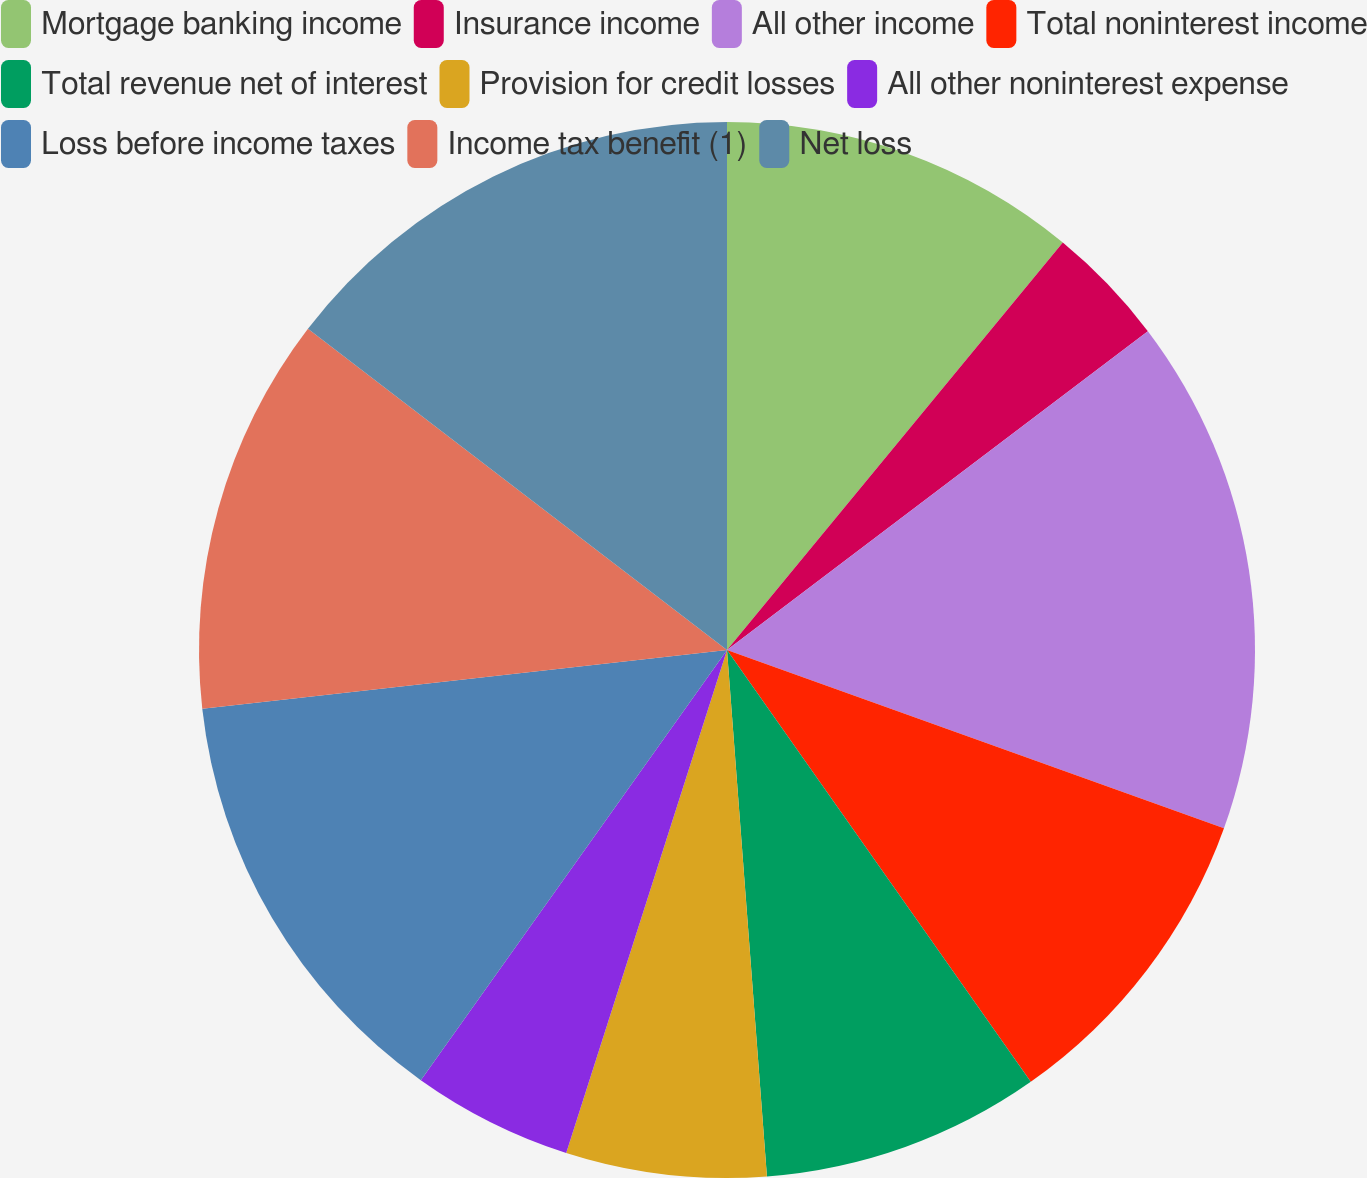Convert chart to OTSL. <chart><loc_0><loc_0><loc_500><loc_500><pie_chart><fcel>Mortgage banking income<fcel>Insurance income<fcel>All other income<fcel>Total noninterest income<fcel>Total revenue net of interest<fcel>Provision for credit losses<fcel>All other noninterest expense<fcel>Loss before income taxes<fcel>Income tax benefit (1)<fcel>Net loss<nl><fcel>10.97%<fcel>3.71%<fcel>15.8%<fcel>9.76%<fcel>8.55%<fcel>6.13%<fcel>4.92%<fcel>13.38%<fcel>12.18%<fcel>14.59%<nl></chart> 